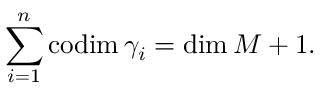<formula> <loc_0><loc_0><loc_500><loc_500>\sum _ { i = 1 } ^ { n } c o d i m \, \gamma _ { i } = d i m \, M + 1 .</formula> 